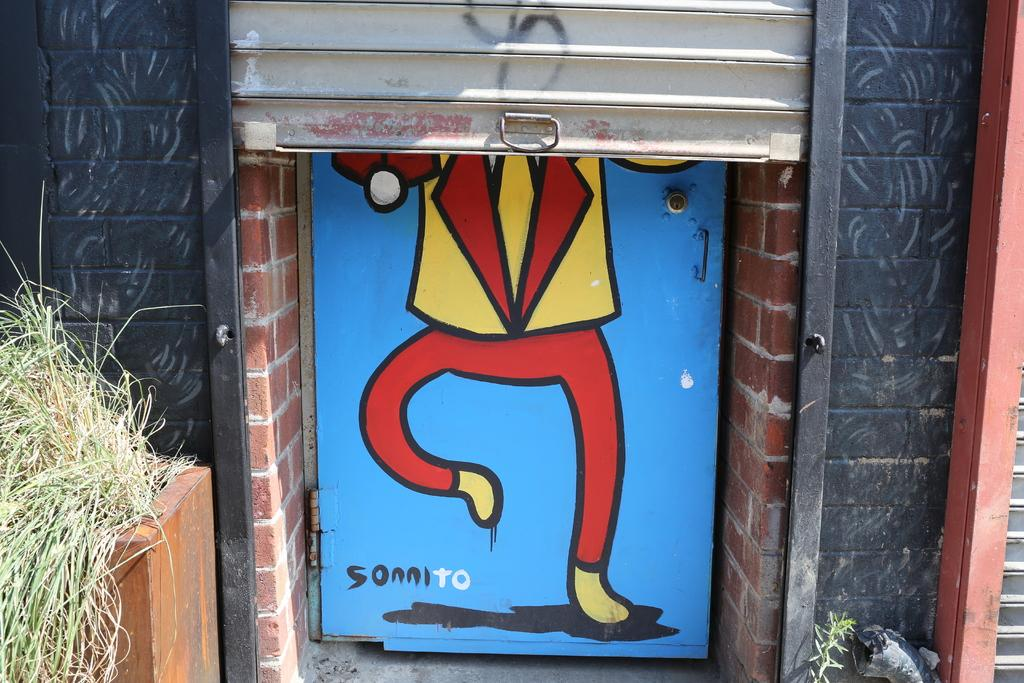What type of structure can be seen in the image? There is a wall in the image. What is hanging on the door in the image? There is a painting on a door in the image. What type of vegetation is present in the image? There are grass plants present in the image. Can you tell me how many rivers are visible in the image? There are no rivers visible in the image; it only features a wall, a painting on a door, and grass plants. 